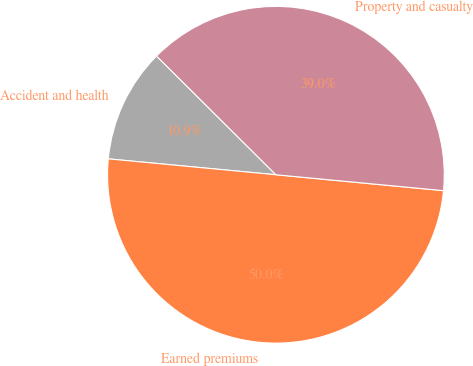Convert chart. <chart><loc_0><loc_0><loc_500><loc_500><pie_chart><fcel>Accident and health<fcel>Earned premiums<fcel>Property and casualty<nl><fcel>10.95%<fcel>50.0%<fcel>39.05%<nl></chart> 